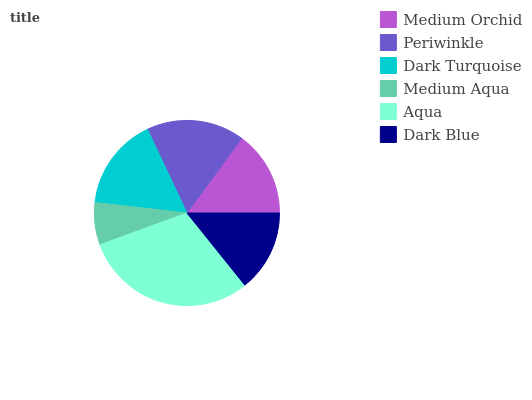Is Medium Aqua the minimum?
Answer yes or no. Yes. Is Aqua the maximum?
Answer yes or no. Yes. Is Periwinkle the minimum?
Answer yes or no. No. Is Periwinkle the maximum?
Answer yes or no. No. Is Periwinkle greater than Medium Orchid?
Answer yes or no. Yes. Is Medium Orchid less than Periwinkle?
Answer yes or no. Yes. Is Medium Orchid greater than Periwinkle?
Answer yes or no. No. Is Periwinkle less than Medium Orchid?
Answer yes or no. No. Is Dark Turquoise the high median?
Answer yes or no. Yes. Is Medium Orchid the low median?
Answer yes or no. Yes. Is Dark Blue the high median?
Answer yes or no. No. Is Periwinkle the low median?
Answer yes or no. No. 